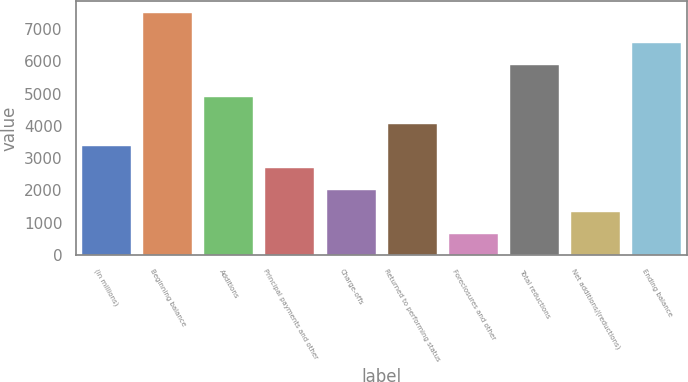Convert chart. <chart><loc_0><loc_0><loc_500><loc_500><bar_chart><fcel>(in millions)<fcel>Beginning balance<fcel>Additions<fcel>Principal payments and other<fcel>Charge-offs<fcel>Returned to performing status<fcel>Foreclosures and other<fcel>Total reductions<fcel>Net additions/(reductions)<fcel>Ending balance<nl><fcel>3384.8<fcel>7496<fcel>4905<fcel>2699.6<fcel>2014.4<fcel>4070<fcel>644<fcel>5892<fcel>1329.2<fcel>6577.2<nl></chart> 